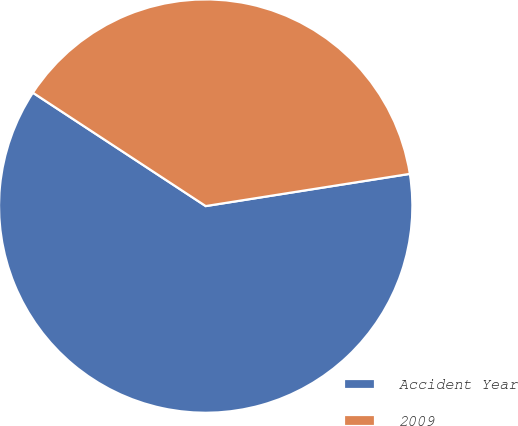Convert chart. <chart><loc_0><loc_0><loc_500><loc_500><pie_chart><fcel>Accident Year<fcel>2009<nl><fcel>61.73%<fcel>38.27%<nl></chart> 